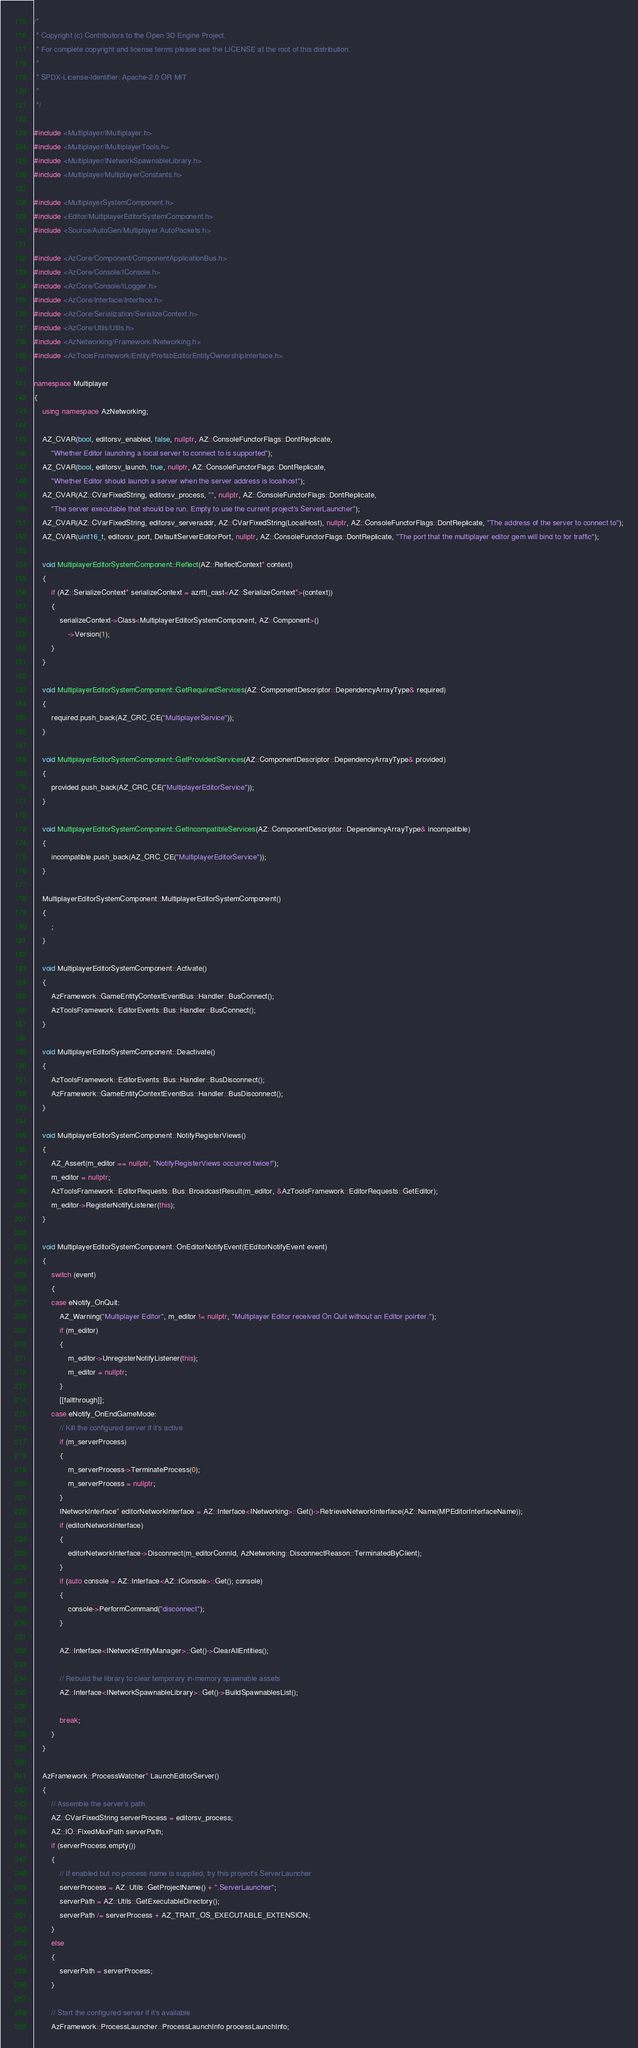Convert code to text. <code><loc_0><loc_0><loc_500><loc_500><_C++_>/*
 * Copyright (c) Contributors to the Open 3D Engine Project.
 * For complete copyright and license terms please see the LICENSE at the root of this distribution.
 *
 * SPDX-License-Identifier: Apache-2.0 OR MIT
 *
 */

#include <Multiplayer/IMultiplayer.h>
#include <Multiplayer/IMultiplayerTools.h>
#include <Multiplayer/INetworkSpawnableLibrary.h>
#include <Multiplayer/MultiplayerConstants.h>

#include <MultiplayerSystemComponent.h>
#include <Editor/MultiplayerEditorSystemComponent.h>
#include <Source/AutoGen/Multiplayer.AutoPackets.h>

#include <AzCore/Component/ComponentApplicationBus.h>
#include <AzCore/Console/IConsole.h>
#include <AzCore/Console/ILogger.h>
#include <AzCore/Interface/Interface.h>
#include <AzCore/Serialization/SerializeContext.h>
#include <AzCore/Utils/Utils.h>
#include <AzNetworking/Framework/INetworking.h>
#include <AzToolsFramework/Entity/PrefabEditorEntityOwnershipInterface.h>

namespace Multiplayer
{
    using namespace AzNetworking;

    AZ_CVAR(bool, editorsv_enabled, false, nullptr, AZ::ConsoleFunctorFlags::DontReplicate,
        "Whether Editor launching a local server to connect to is supported");
    AZ_CVAR(bool, editorsv_launch, true, nullptr, AZ::ConsoleFunctorFlags::DontReplicate,
        "Whether Editor should launch a server when the server address is localhost");
    AZ_CVAR(AZ::CVarFixedString, editorsv_process, "", nullptr, AZ::ConsoleFunctorFlags::DontReplicate,
        "The server executable that should be run. Empty to use the current project's ServerLauncher");
    AZ_CVAR(AZ::CVarFixedString, editorsv_serveraddr, AZ::CVarFixedString(LocalHost), nullptr, AZ::ConsoleFunctorFlags::DontReplicate, "The address of the server to connect to");
    AZ_CVAR(uint16_t, editorsv_port, DefaultServerEditorPort, nullptr, AZ::ConsoleFunctorFlags::DontReplicate, "The port that the multiplayer editor gem will bind to for traffic");

    void MultiplayerEditorSystemComponent::Reflect(AZ::ReflectContext* context)
    {
        if (AZ::SerializeContext* serializeContext = azrtti_cast<AZ::SerializeContext*>(context))
        {
            serializeContext->Class<MultiplayerEditorSystemComponent, AZ::Component>()
                ->Version(1);
        }
    }

    void MultiplayerEditorSystemComponent::GetRequiredServices(AZ::ComponentDescriptor::DependencyArrayType& required)
    {
        required.push_back(AZ_CRC_CE("MultiplayerService"));
    }

    void MultiplayerEditorSystemComponent::GetProvidedServices(AZ::ComponentDescriptor::DependencyArrayType& provided)
    {
        provided.push_back(AZ_CRC_CE("MultiplayerEditorService"));
    }

    void MultiplayerEditorSystemComponent::GetIncompatibleServices(AZ::ComponentDescriptor::DependencyArrayType& incompatible)
    {
        incompatible.push_back(AZ_CRC_CE("MultiplayerEditorService"));
    }

    MultiplayerEditorSystemComponent::MultiplayerEditorSystemComponent()
    {
        ;
    }

    void MultiplayerEditorSystemComponent::Activate()
    {
        AzFramework::GameEntityContextEventBus::Handler::BusConnect();
        AzToolsFramework::EditorEvents::Bus::Handler::BusConnect();
    }

    void MultiplayerEditorSystemComponent::Deactivate()
    {
        AzToolsFramework::EditorEvents::Bus::Handler::BusDisconnect();
        AzFramework::GameEntityContextEventBus::Handler::BusDisconnect();
    }

    void MultiplayerEditorSystemComponent::NotifyRegisterViews()
    {
        AZ_Assert(m_editor == nullptr, "NotifyRegisterViews occurred twice!");
        m_editor = nullptr;
        AzToolsFramework::EditorRequests::Bus::BroadcastResult(m_editor, &AzToolsFramework::EditorRequests::GetEditor);
        m_editor->RegisterNotifyListener(this);
    }

    void MultiplayerEditorSystemComponent::OnEditorNotifyEvent(EEditorNotifyEvent event)
    {
        switch (event)
        {
        case eNotify_OnQuit:
            AZ_Warning("Multiplayer Editor", m_editor != nullptr, "Multiplayer Editor received On Quit without an Editor pointer.");
            if (m_editor)
            {
                m_editor->UnregisterNotifyListener(this);
                m_editor = nullptr;
            }
            [[fallthrough]];
        case eNotify_OnEndGameMode:
            // Kill the configured server if it's active
            if (m_serverProcess)
            {
                m_serverProcess->TerminateProcess(0);
                m_serverProcess = nullptr;
            }
            INetworkInterface* editorNetworkInterface = AZ::Interface<INetworking>::Get()->RetrieveNetworkInterface(AZ::Name(MPEditorInterfaceName));
            if (editorNetworkInterface)
            {
                editorNetworkInterface->Disconnect(m_editorConnId, AzNetworking::DisconnectReason::TerminatedByClient);
            }
            if (auto console = AZ::Interface<AZ::IConsole>::Get(); console)
            {
                console->PerformCommand("disconnect");
            }

            AZ::Interface<INetworkEntityManager>::Get()->ClearAllEntities();

            // Rebuild the library to clear temporary in-memory spawnable assets
            AZ::Interface<INetworkSpawnableLibrary>::Get()->BuildSpawnablesList();

            break;
        }
    }

    AzFramework::ProcessWatcher* LaunchEditorServer()
    {
        // Assemble the server's path
        AZ::CVarFixedString serverProcess = editorsv_process;
        AZ::IO::FixedMaxPath serverPath;
        if (serverProcess.empty())
        {
            // If enabled but no process name is supplied, try this project's ServerLauncher
            serverProcess = AZ::Utils::GetProjectName() + ".ServerLauncher";
            serverPath = AZ::Utils::GetExecutableDirectory();
            serverPath /= serverProcess + AZ_TRAIT_OS_EXECUTABLE_EXTENSION;
        }
        else
        {
            serverPath = serverProcess;
        }

        // Start the configured server if it's available
        AzFramework::ProcessLauncher::ProcessLaunchInfo processLaunchInfo;</code> 